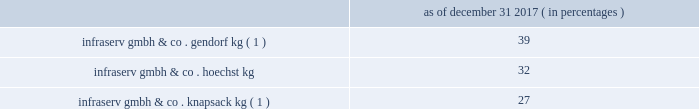Table of contents other equity method investments infraservs .
We hold indirect ownership interests in several german infraserv groups that own and develop industrial parks and provide on-site general and administrative support to tenants .
Our ownership interest in the equity investments in infraserv affiliates are as follows : as of december 31 , 2017 ( in percentages ) infraserv gmbh & co .
Gendorf kg ( 1 ) ................................................................................................... .
39 .
Infraserv gmbh & co .
Knapsack kg ( 1 ) ................................................................................................ .
27 ______________________________ ( 1 ) see note 29 - subsequent events in the accompanying consolidated financial statements for further information .
Research and development our business models leverage innovation and conduct research and development activities to develop new , and optimize existing , production technologies , as well as to develop commercially viable new products and applications .
Research and development expense was $ 72 million , $ 78 million and $ 119 million for the years ended december 31 , 2017 , 2016 and 2015 , respectively .
We consider the amounts spent during each of the last three fiscal years on research and development activities to be sufficient to execute our current strategic initiatives .
Intellectual property we attach importance to protecting our intellectual property , including safeguarding our confidential information and through our patents , trademarks and copyrights , in order to preserve our investment in research and development , manufacturing and marketing .
Patents may cover processes , equipment , products , intermediate products and product uses .
We also seek to register trademarks as a means of protecting the brand names of our company and products .
Patents .
In most industrial countries , patent protection exists for new substances and formulations , as well as for certain unique applications and production processes .
However , we do business in regions of the world where intellectual property protection may be limited and difficult to enforce .
Confidential information .
We maintain stringent information security policies and procedures wherever we do business .
Such information security policies and procedures include data encryption , controls over the disclosure and safekeeping of confidential information and trade secrets , as well as employee awareness training .
Trademarks .
Amcel ae , aoplus ae , ateva ae , avicor ae , celanese ae , celanex ae , celcon ae , celfx ae , celstran ae , celvolit ae , clarifoil ae , dur- o-set ae , ecomid ae , ecovae ae , forflex ae , forprene ae , frianyl ae , fortron ae , ghr ae , gumfit ae , gur ae , hostaform ae , laprene ae , metalx ae , mowilith ae , mt ae , nilamid ae , nivionplast ae , nutrinova ae , nylfor ae , pibiflex ae , pibifor ae , pibiter ae , polifor ae , resyn ae , riteflex ae , slidex ae , sofprene ae , sofpur ae , sunett ae , talcoprene ae , tecnoprene ae , thermx ae , tufcor ae , vantage ae , vectra ae , vinac ae , vinamul ae , vitaldose ae , zenite ae and certain other branded products and services named in this document are registered or reserved trademarks or service marks owned or licensed by celanese .
The foregoing is not intended to be an exhaustive or comprehensive list of all registered or reserved trademarks and service marks owned or licensed by celanese .
Fortron ae is a registered trademark of fortron industries llc .
Hostaform ae is a registered trademark of hoechst gmbh .
Mowilith ae and nilamid ae are registered trademarks of celanese in most european countries .
We monitor competitive developments and defend against infringements on our intellectual property rights .
Neither celanese nor any particular business segment is materially dependent upon any one patent , trademark , copyright or trade secret .
Environmental and other regulation matters pertaining to environmental and other regulations are discussed in item 1a .
Risk factors , as well as note 2 - summary of accounting policies , note 16 - environmental and note 24 - commitments and contingencies in the accompanying consolidated financial statements. .
What is the percentage change in research and development expense from 2015 to 2016? 
Computations: ((78 - 119) / 119)
Answer: -0.34454. Table of contents other equity method investments infraservs .
We hold indirect ownership interests in several german infraserv groups that own and develop industrial parks and provide on-site general and administrative support to tenants .
Our ownership interest in the equity investments in infraserv affiliates are as follows : as of december 31 , 2017 ( in percentages ) infraserv gmbh & co .
Gendorf kg ( 1 ) ................................................................................................... .
39 .
Infraserv gmbh & co .
Knapsack kg ( 1 ) ................................................................................................ .
27 ______________________________ ( 1 ) see note 29 - subsequent events in the accompanying consolidated financial statements for further information .
Research and development our business models leverage innovation and conduct research and development activities to develop new , and optimize existing , production technologies , as well as to develop commercially viable new products and applications .
Research and development expense was $ 72 million , $ 78 million and $ 119 million for the years ended december 31 , 2017 , 2016 and 2015 , respectively .
We consider the amounts spent during each of the last three fiscal years on research and development activities to be sufficient to execute our current strategic initiatives .
Intellectual property we attach importance to protecting our intellectual property , including safeguarding our confidential information and through our patents , trademarks and copyrights , in order to preserve our investment in research and development , manufacturing and marketing .
Patents may cover processes , equipment , products , intermediate products and product uses .
We also seek to register trademarks as a means of protecting the brand names of our company and products .
Patents .
In most industrial countries , patent protection exists for new substances and formulations , as well as for certain unique applications and production processes .
However , we do business in regions of the world where intellectual property protection may be limited and difficult to enforce .
Confidential information .
We maintain stringent information security policies and procedures wherever we do business .
Such information security policies and procedures include data encryption , controls over the disclosure and safekeeping of confidential information and trade secrets , as well as employee awareness training .
Trademarks .
Amcel ae , aoplus ae , ateva ae , avicor ae , celanese ae , celanex ae , celcon ae , celfx ae , celstran ae , celvolit ae , clarifoil ae , dur- o-set ae , ecomid ae , ecovae ae , forflex ae , forprene ae , frianyl ae , fortron ae , ghr ae , gumfit ae , gur ae , hostaform ae , laprene ae , metalx ae , mowilith ae , mt ae , nilamid ae , nivionplast ae , nutrinova ae , nylfor ae , pibiflex ae , pibifor ae , pibiter ae , polifor ae , resyn ae , riteflex ae , slidex ae , sofprene ae , sofpur ae , sunett ae , talcoprene ae , tecnoprene ae , thermx ae , tufcor ae , vantage ae , vectra ae , vinac ae , vinamul ae , vitaldose ae , zenite ae and certain other branded products and services named in this document are registered or reserved trademarks or service marks owned or licensed by celanese .
The foregoing is not intended to be an exhaustive or comprehensive list of all registered or reserved trademarks and service marks owned or licensed by celanese .
Fortron ae is a registered trademark of fortron industries llc .
Hostaform ae is a registered trademark of hoechst gmbh .
Mowilith ae and nilamid ae are registered trademarks of celanese in most european countries .
We monitor competitive developments and defend against infringements on our intellectual property rights .
Neither celanese nor any particular business segment is materially dependent upon any one patent , trademark , copyright or trade secret .
Environmental and other regulation matters pertaining to environmental and other regulations are discussed in item 1a .
Risk factors , as well as note 2 - summary of accounting policies , note 16 - environmental and note 24 - commitments and contingencies in the accompanying consolidated financial statements. .
What was the total research and development from december 312017 to 2015 in millions? 
Rationale: the total amount is the sum of all amounts
Computations: ((72 + 78) + 119)
Answer: 269.0. Table of contents other equity method investments infraservs .
We hold indirect ownership interests in several german infraserv groups that own and develop industrial parks and provide on-site general and administrative support to tenants .
Our ownership interest in the equity investments in infraserv affiliates are as follows : as of december 31 , 2017 ( in percentages ) infraserv gmbh & co .
Gendorf kg ( 1 ) ................................................................................................... .
39 .
Infraserv gmbh & co .
Knapsack kg ( 1 ) ................................................................................................ .
27 ______________________________ ( 1 ) see note 29 - subsequent events in the accompanying consolidated financial statements for further information .
Research and development our business models leverage innovation and conduct research and development activities to develop new , and optimize existing , production technologies , as well as to develop commercially viable new products and applications .
Research and development expense was $ 72 million , $ 78 million and $ 119 million for the years ended december 31 , 2017 , 2016 and 2015 , respectively .
We consider the amounts spent during each of the last three fiscal years on research and development activities to be sufficient to execute our current strategic initiatives .
Intellectual property we attach importance to protecting our intellectual property , including safeguarding our confidential information and through our patents , trademarks and copyrights , in order to preserve our investment in research and development , manufacturing and marketing .
Patents may cover processes , equipment , products , intermediate products and product uses .
We also seek to register trademarks as a means of protecting the brand names of our company and products .
Patents .
In most industrial countries , patent protection exists for new substances and formulations , as well as for certain unique applications and production processes .
However , we do business in regions of the world where intellectual property protection may be limited and difficult to enforce .
Confidential information .
We maintain stringent information security policies and procedures wherever we do business .
Such information security policies and procedures include data encryption , controls over the disclosure and safekeeping of confidential information and trade secrets , as well as employee awareness training .
Trademarks .
Amcel ae , aoplus ae , ateva ae , avicor ae , celanese ae , celanex ae , celcon ae , celfx ae , celstran ae , celvolit ae , clarifoil ae , dur- o-set ae , ecomid ae , ecovae ae , forflex ae , forprene ae , frianyl ae , fortron ae , ghr ae , gumfit ae , gur ae , hostaform ae , laprene ae , metalx ae , mowilith ae , mt ae , nilamid ae , nivionplast ae , nutrinova ae , nylfor ae , pibiflex ae , pibifor ae , pibiter ae , polifor ae , resyn ae , riteflex ae , slidex ae , sofprene ae , sofpur ae , sunett ae , talcoprene ae , tecnoprene ae , thermx ae , tufcor ae , vantage ae , vectra ae , vinac ae , vinamul ae , vitaldose ae , zenite ae and certain other branded products and services named in this document are registered or reserved trademarks or service marks owned or licensed by celanese .
The foregoing is not intended to be an exhaustive or comprehensive list of all registered or reserved trademarks and service marks owned or licensed by celanese .
Fortron ae is a registered trademark of fortron industries llc .
Hostaform ae is a registered trademark of hoechst gmbh .
Mowilith ae and nilamid ae are registered trademarks of celanese in most european countries .
We monitor competitive developments and defend against infringements on our intellectual property rights .
Neither celanese nor any particular business segment is materially dependent upon any one patent , trademark , copyright or trade secret .
Environmental and other regulation matters pertaining to environmental and other regulations are discussed in item 1a .
Risk factors , as well as note 2 - summary of accounting policies , note 16 - environmental and note 24 - commitments and contingencies in the accompanying consolidated financial statements. .
What is the percentage change in research and development expense from 2016 to 2017? 
Computations: ((72 - 78) / 78)
Answer: -0.07692. 